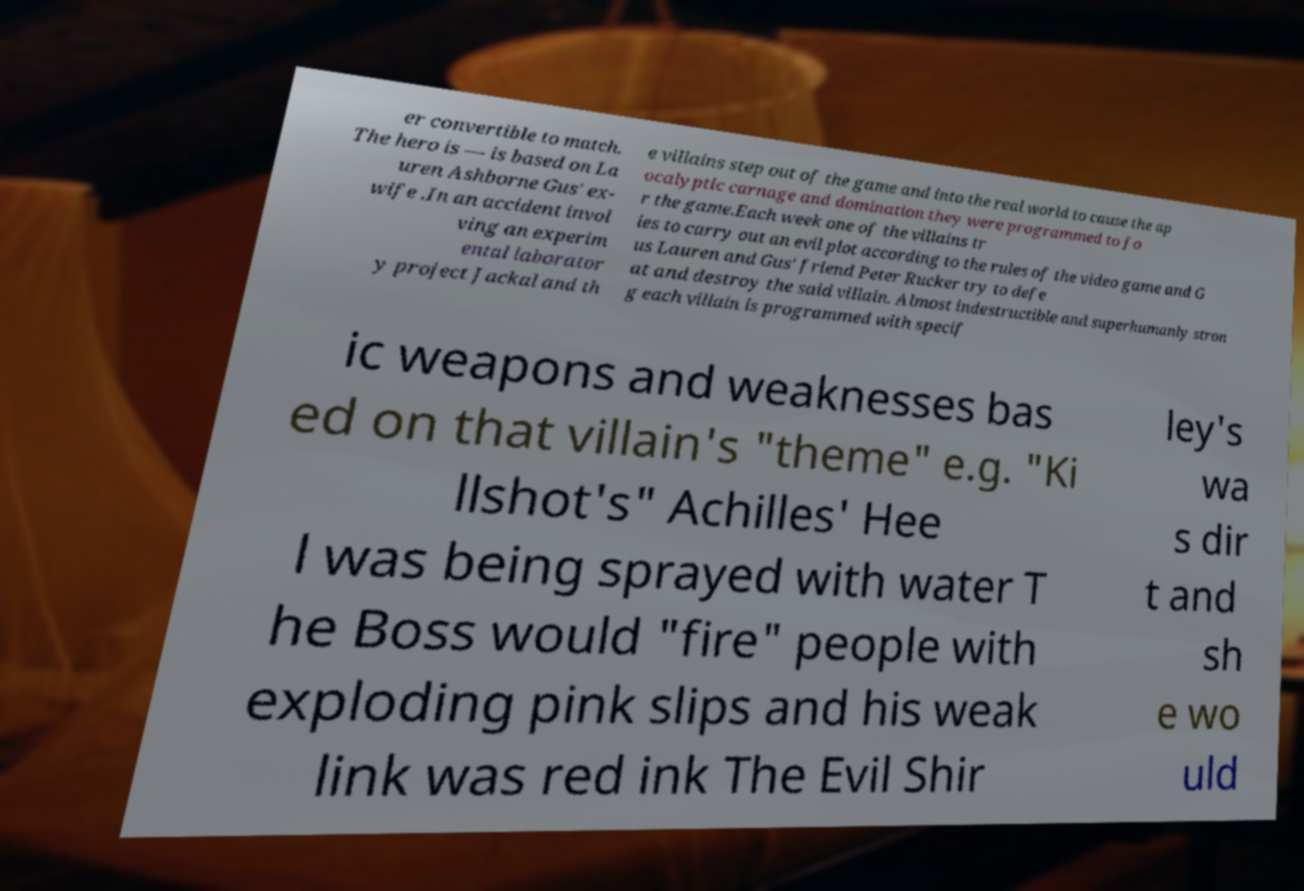Can you accurately transcribe the text from the provided image for me? er convertible to match. The hero is — is based on La uren Ashborne Gus' ex- wife .In an accident invol ving an experim ental laborator y project Jackal and th e villains step out of the game and into the real world to cause the ap ocalyptic carnage and domination they were programmed to fo r the game.Each week one of the villains tr ies to carry out an evil plot according to the rules of the video game and G us Lauren and Gus' friend Peter Rucker try to defe at and destroy the said villain. Almost indestructible and superhumanly stron g each villain is programmed with specif ic weapons and weaknesses bas ed on that villain's "theme" e.g. "Ki llshot's" Achilles' Hee l was being sprayed with water T he Boss would "fire" people with exploding pink slips and his weak link was red ink The Evil Shir ley's wa s dir t and sh e wo uld 